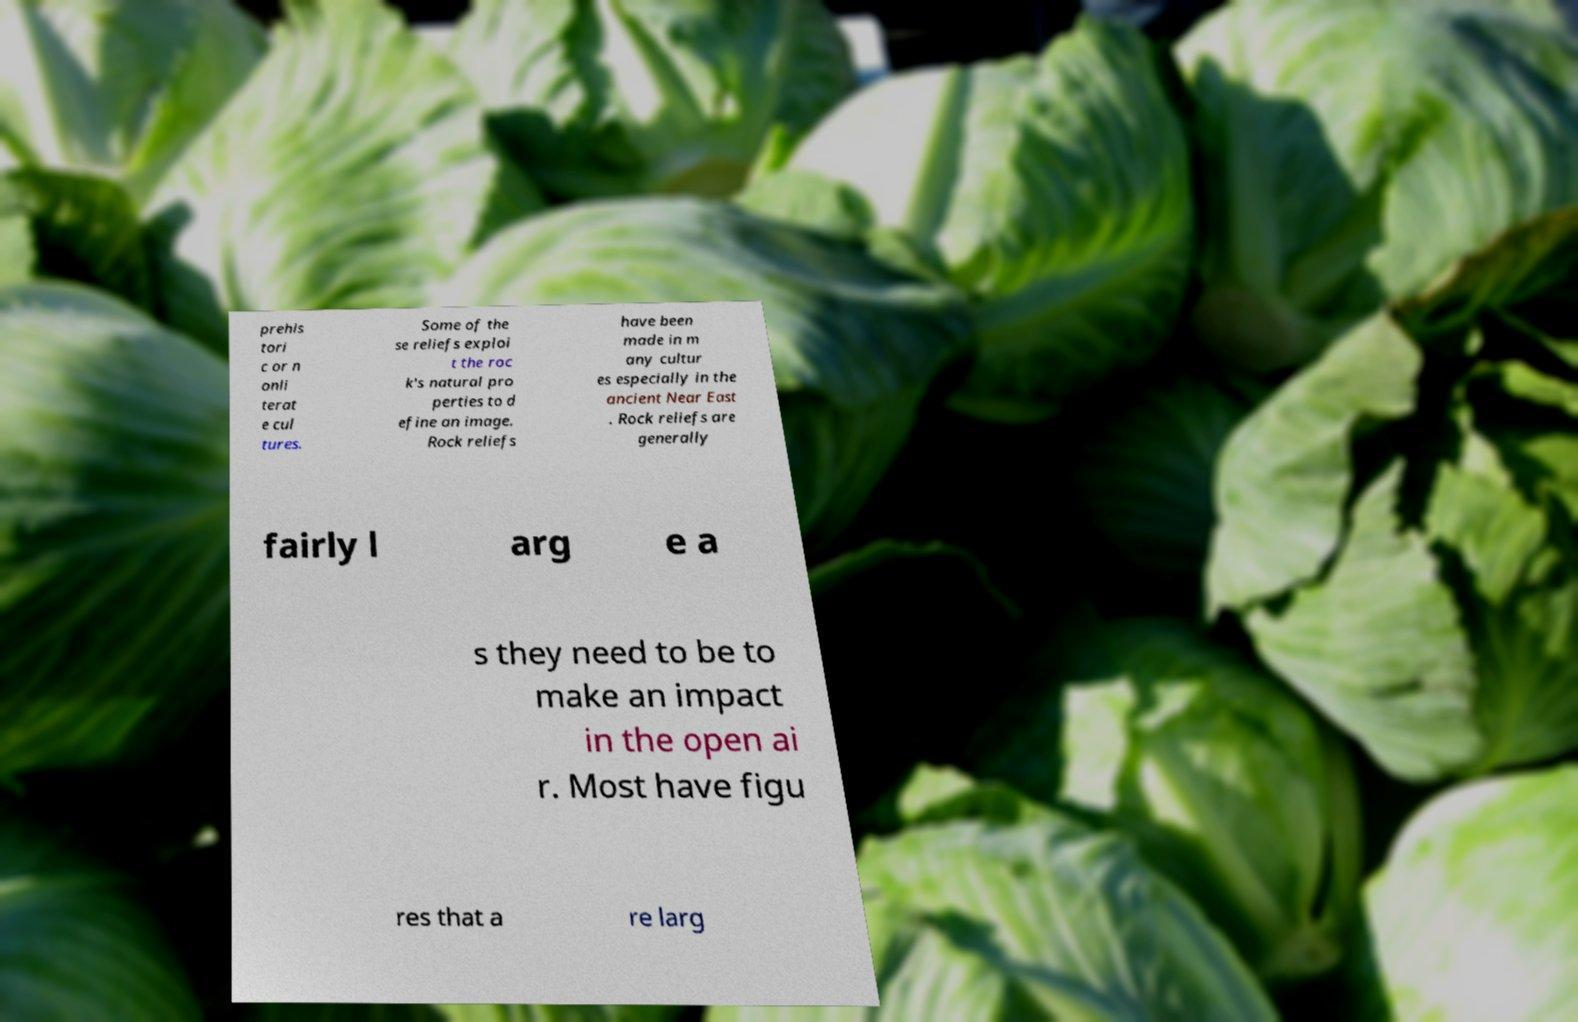I need the written content from this picture converted into text. Can you do that? prehis tori c or n onli terat e cul tures. Some of the se reliefs exploi t the roc k's natural pro perties to d efine an image. Rock reliefs have been made in m any cultur es especially in the ancient Near East . Rock reliefs are generally fairly l arg e a s they need to be to make an impact in the open ai r. Most have figu res that a re larg 